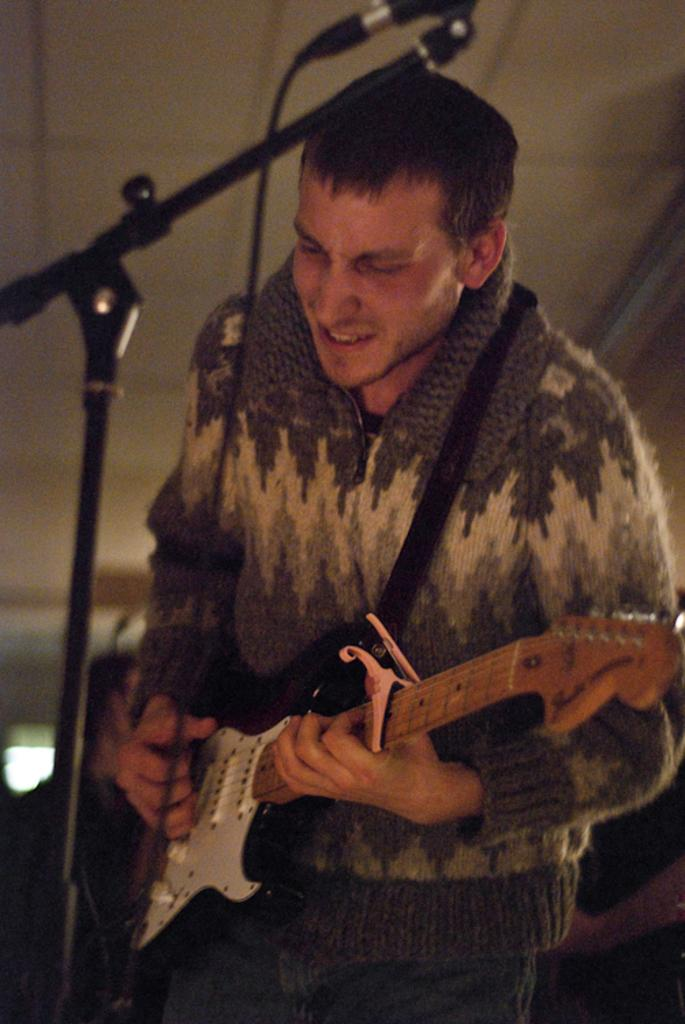What is the main subject of the image? There is a man standing in the center of the image. What is the man doing in the image? The man is playing a guitar. What object is located on the left side of the image? There is a mic stand on the left side of the image. Can you see any worms crawling on the guitar strings in the image? There are no worms present in the image; it features a man playing a guitar and a mic stand. 